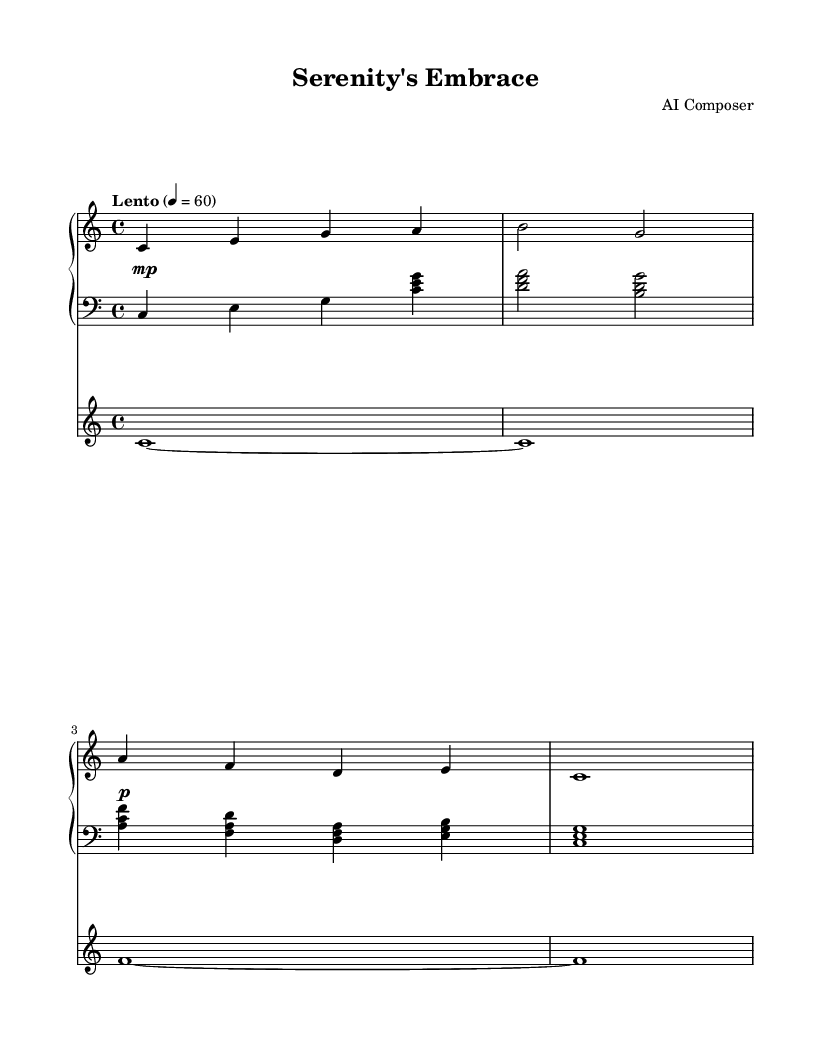What is the key signature of this music? The key signature is indicated by the absence of sharps or flats at the beginning of the staff. Since it is positioned on the C line, it is C major.
Answer: C major What is the time signature of the piece? The time signature is noted at the beginning of the staff with two numbers, indicating how many beats are in each measure and what note value gets the beat. Here, it is 4/4, meaning there are four beats per measure with a quarter note receiving one beat.
Answer: 4/4 What is the tempo marking for this piece? The tempo marking is written at the beginning of the sheet music and mentions "Lento," which indicates a slow pace, along with a BPM (beats per minute) marking of 60.
Answer: Lento 4 = 60 How many measures does the piece contain? To find the number of measures, we count the distinct sections separated by vertical lines on the sheet. There are four measures in the piano upper part and five in the piano lower part, but when considering the whole score, there are effectively four as dictated by the upper staff.
Answer: 4 What instruments are featured in the score? The score specifies the instrumentation at the beginning with the names of each staff. There are two staff sections for the piano and a separate staff for the strings.
Answer: Piano and Strings What dynamics are indicated in this piece? The dynamics can be found notated within the score, indicating how loud or soft sections should be played. Here, we see a soft marking (piano) and a softer marking (mezzo-piano) indicated.
Answer: Piano and mezzo-piano What is the title of this music? The title is displayed prominently at the top of the sheet music in the header section, which identifies the composition.
Answer: Serenity's Embrace 